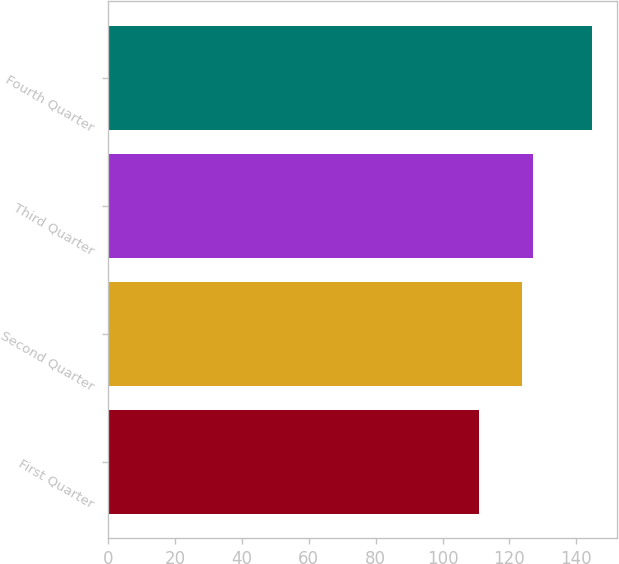<chart> <loc_0><loc_0><loc_500><loc_500><bar_chart><fcel>First Quarter<fcel>Second Quarter<fcel>Third Quarter<fcel>Fourth Quarter<nl><fcel>110.91<fcel>123.65<fcel>127.04<fcel>144.81<nl></chart> 